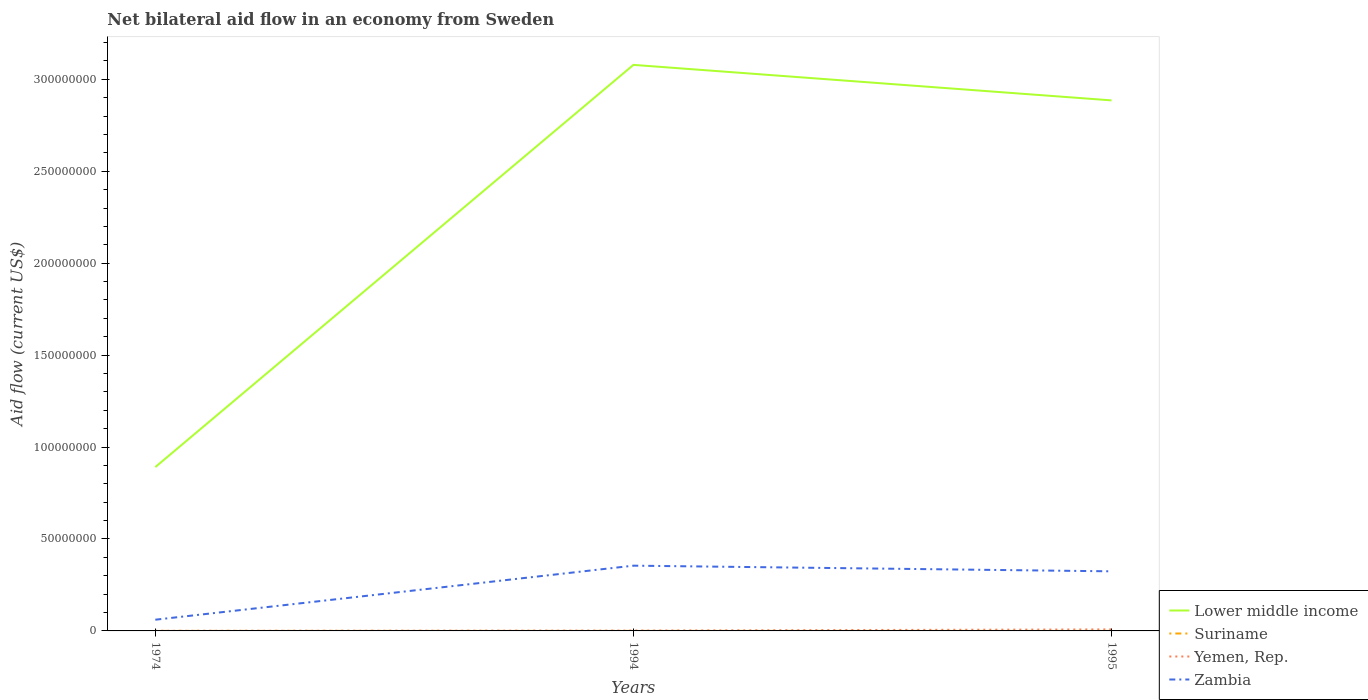Does the line corresponding to Lower middle income intersect with the line corresponding to Zambia?
Ensure brevity in your answer.  No. Is the number of lines equal to the number of legend labels?
Keep it short and to the point. Yes. Across all years, what is the maximum net bilateral aid flow in Yemen, Rep.?
Provide a succinct answer. 7.00e+04. In which year was the net bilateral aid flow in Zambia maximum?
Ensure brevity in your answer.  1974. What is the difference between the highest and the second highest net bilateral aid flow in Zambia?
Your answer should be compact. 2.94e+07. How many lines are there?
Offer a very short reply. 4. How many legend labels are there?
Your answer should be compact. 4. What is the title of the graph?
Keep it short and to the point. Net bilateral aid flow in an economy from Sweden. Does "Guinea" appear as one of the legend labels in the graph?
Give a very brief answer. No. What is the label or title of the X-axis?
Ensure brevity in your answer.  Years. What is the Aid flow (current US$) of Lower middle income in 1974?
Your answer should be compact. 8.91e+07. What is the Aid flow (current US$) in Zambia in 1974?
Provide a succinct answer. 6.10e+06. What is the Aid flow (current US$) in Lower middle income in 1994?
Your answer should be very brief. 3.08e+08. What is the Aid flow (current US$) in Suriname in 1994?
Your response must be concise. 2.00e+04. What is the Aid flow (current US$) of Zambia in 1994?
Provide a short and direct response. 3.55e+07. What is the Aid flow (current US$) in Lower middle income in 1995?
Provide a short and direct response. 2.89e+08. What is the Aid flow (current US$) in Suriname in 1995?
Your answer should be very brief. 10000. What is the Aid flow (current US$) of Yemen, Rep. in 1995?
Your answer should be compact. 8.30e+05. What is the Aid flow (current US$) of Zambia in 1995?
Make the answer very short. 3.24e+07. Across all years, what is the maximum Aid flow (current US$) of Lower middle income?
Your answer should be very brief. 3.08e+08. Across all years, what is the maximum Aid flow (current US$) of Suriname?
Provide a short and direct response. 2.00e+04. Across all years, what is the maximum Aid flow (current US$) of Yemen, Rep.?
Offer a very short reply. 8.30e+05. Across all years, what is the maximum Aid flow (current US$) in Zambia?
Offer a terse response. 3.55e+07. Across all years, what is the minimum Aid flow (current US$) of Lower middle income?
Provide a short and direct response. 8.91e+07. Across all years, what is the minimum Aid flow (current US$) of Zambia?
Your answer should be compact. 6.10e+06. What is the total Aid flow (current US$) of Lower middle income in the graph?
Your answer should be very brief. 6.86e+08. What is the total Aid flow (current US$) in Yemen, Rep. in the graph?
Provide a short and direct response. 1.09e+06. What is the total Aid flow (current US$) in Zambia in the graph?
Offer a very short reply. 7.40e+07. What is the difference between the Aid flow (current US$) of Lower middle income in 1974 and that in 1994?
Make the answer very short. -2.19e+08. What is the difference between the Aid flow (current US$) of Suriname in 1974 and that in 1994?
Provide a short and direct response. 0. What is the difference between the Aid flow (current US$) of Zambia in 1974 and that in 1994?
Provide a short and direct response. -2.94e+07. What is the difference between the Aid flow (current US$) in Lower middle income in 1974 and that in 1995?
Provide a succinct answer. -1.99e+08. What is the difference between the Aid flow (current US$) in Suriname in 1974 and that in 1995?
Offer a very short reply. 10000. What is the difference between the Aid flow (current US$) in Yemen, Rep. in 1974 and that in 1995?
Offer a terse response. -7.60e+05. What is the difference between the Aid flow (current US$) in Zambia in 1974 and that in 1995?
Provide a short and direct response. -2.63e+07. What is the difference between the Aid flow (current US$) in Lower middle income in 1994 and that in 1995?
Provide a succinct answer. 1.93e+07. What is the difference between the Aid flow (current US$) of Yemen, Rep. in 1994 and that in 1995?
Provide a short and direct response. -6.40e+05. What is the difference between the Aid flow (current US$) in Zambia in 1994 and that in 1995?
Your answer should be compact. 3.08e+06. What is the difference between the Aid flow (current US$) in Lower middle income in 1974 and the Aid flow (current US$) in Suriname in 1994?
Your answer should be compact. 8.91e+07. What is the difference between the Aid flow (current US$) of Lower middle income in 1974 and the Aid flow (current US$) of Yemen, Rep. in 1994?
Provide a succinct answer. 8.89e+07. What is the difference between the Aid flow (current US$) in Lower middle income in 1974 and the Aid flow (current US$) in Zambia in 1994?
Make the answer very short. 5.36e+07. What is the difference between the Aid flow (current US$) in Suriname in 1974 and the Aid flow (current US$) in Zambia in 1994?
Ensure brevity in your answer.  -3.55e+07. What is the difference between the Aid flow (current US$) in Yemen, Rep. in 1974 and the Aid flow (current US$) in Zambia in 1994?
Your answer should be compact. -3.54e+07. What is the difference between the Aid flow (current US$) of Lower middle income in 1974 and the Aid flow (current US$) of Suriname in 1995?
Provide a succinct answer. 8.91e+07. What is the difference between the Aid flow (current US$) of Lower middle income in 1974 and the Aid flow (current US$) of Yemen, Rep. in 1995?
Your response must be concise. 8.83e+07. What is the difference between the Aid flow (current US$) of Lower middle income in 1974 and the Aid flow (current US$) of Zambia in 1995?
Keep it short and to the point. 5.67e+07. What is the difference between the Aid flow (current US$) in Suriname in 1974 and the Aid flow (current US$) in Yemen, Rep. in 1995?
Ensure brevity in your answer.  -8.10e+05. What is the difference between the Aid flow (current US$) in Suriname in 1974 and the Aid flow (current US$) in Zambia in 1995?
Offer a terse response. -3.24e+07. What is the difference between the Aid flow (current US$) of Yemen, Rep. in 1974 and the Aid flow (current US$) of Zambia in 1995?
Offer a very short reply. -3.23e+07. What is the difference between the Aid flow (current US$) of Lower middle income in 1994 and the Aid flow (current US$) of Suriname in 1995?
Offer a very short reply. 3.08e+08. What is the difference between the Aid flow (current US$) in Lower middle income in 1994 and the Aid flow (current US$) in Yemen, Rep. in 1995?
Give a very brief answer. 3.07e+08. What is the difference between the Aid flow (current US$) in Lower middle income in 1994 and the Aid flow (current US$) in Zambia in 1995?
Make the answer very short. 2.75e+08. What is the difference between the Aid flow (current US$) of Suriname in 1994 and the Aid flow (current US$) of Yemen, Rep. in 1995?
Offer a terse response. -8.10e+05. What is the difference between the Aid flow (current US$) in Suriname in 1994 and the Aid flow (current US$) in Zambia in 1995?
Offer a very short reply. -3.24e+07. What is the difference between the Aid flow (current US$) in Yemen, Rep. in 1994 and the Aid flow (current US$) in Zambia in 1995?
Keep it short and to the point. -3.22e+07. What is the average Aid flow (current US$) in Lower middle income per year?
Offer a terse response. 2.28e+08. What is the average Aid flow (current US$) in Suriname per year?
Keep it short and to the point. 1.67e+04. What is the average Aid flow (current US$) in Yemen, Rep. per year?
Ensure brevity in your answer.  3.63e+05. What is the average Aid flow (current US$) of Zambia per year?
Ensure brevity in your answer.  2.47e+07. In the year 1974, what is the difference between the Aid flow (current US$) in Lower middle income and Aid flow (current US$) in Suriname?
Your answer should be very brief. 8.91e+07. In the year 1974, what is the difference between the Aid flow (current US$) in Lower middle income and Aid flow (current US$) in Yemen, Rep.?
Make the answer very short. 8.90e+07. In the year 1974, what is the difference between the Aid flow (current US$) of Lower middle income and Aid flow (current US$) of Zambia?
Your answer should be very brief. 8.30e+07. In the year 1974, what is the difference between the Aid flow (current US$) in Suriname and Aid flow (current US$) in Zambia?
Provide a short and direct response. -6.08e+06. In the year 1974, what is the difference between the Aid flow (current US$) of Yemen, Rep. and Aid flow (current US$) of Zambia?
Make the answer very short. -6.03e+06. In the year 1994, what is the difference between the Aid flow (current US$) in Lower middle income and Aid flow (current US$) in Suriname?
Your response must be concise. 3.08e+08. In the year 1994, what is the difference between the Aid flow (current US$) in Lower middle income and Aid flow (current US$) in Yemen, Rep.?
Your response must be concise. 3.08e+08. In the year 1994, what is the difference between the Aid flow (current US$) in Lower middle income and Aid flow (current US$) in Zambia?
Make the answer very short. 2.72e+08. In the year 1994, what is the difference between the Aid flow (current US$) of Suriname and Aid flow (current US$) of Yemen, Rep.?
Provide a short and direct response. -1.70e+05. In the year 1994, what is the difference between the Aid flow (current US$) of Suriname and Aid flow (current US$) of Zambia?
Your response must be concise. -3.55e+07. In the year 1994, what is the difference between the Aid flow (current US$) in Yemen, Rep. and Aid flow (current US$) in Zambia?
Your answer should be compact. -3.53e+07. In the year 1995, what is the difference between the Aid flow (current US$) in Lower middle income and Aid flow (current US$) in Suriname?
Give a very brief answer. 2.89e+08. In the year 1995, what is the difference between the Aid flow (current US$) of Lower middle income and Aid flow (current US$) of Yemen, Rep.?
Offer a very short reply. 2.88e+08. In the year 1995, what is the difference between the Aid flow (current US$) in Lower middle income and Aid flow (current US$) in Zambia?
Provide a short and direct response. 2.56e+08. In the year 1995, what is the difference between the Aid flow (current US$) in Suriname and Aid flow (current US$) in Yemen, Rep.?
Your answer should be very brief. -8.20e+05. In the year 1995, what is the difference between the Aid flow (current US$) of Suriname and Aid flow (current US$) of Zambia?
Provide a short and direct response. -3.24e+07. In the year 1995, what is the difference between the Aid flow (current US$) in Yemen, Rep. and Aid flow (current US$) in Zambia?
Make the answer very short. -3.16e+07. What is the ratio of the Aid flow (current US$) in Lower middle income in 1974 to that in 1994?
Make the answer very short. 0.29. What is the ratio of the Aid flow (current US$) in Yemen, Rep. in 1974 to that in 1994?
Provide a succinct answer. 0.37. What is the ratio of the Aid flow (current US$) in Zambia in 1974 to that in 1994?
Keep it short and to the point. 0.17. What is the ratio of the Aid flow (current US$) in Lower middle income in 1974 to that in 1995?
Make the answer very short. 0.31. What is the ratio of the Aid flow (current US$) in Suriname in 1974 to that in 1995?
Your answer should be very brief. 2. What is the ratio of the Aid flow (current US$) of Yemen, Rep. in 1974 to that in 1995?
Keep it short and to the point. 0.08. What is the ratio of the Aid flow (current US$) of Zambia in 1974 to that in 1995?
Ensure brevity in your answer.  0.19. What is the ratio of the Aid flow (current US$) of Lower middle income in 1994 to that in 1995?
Your answer should be compact. 1.07. What is the ratio of the Aid flow (current US$) in Yemen, Rep. in 1994 to that in 1995?
Give a very brief answer. 0.23. What is the ratio of the Aid flow (current US$) of Zambia in 1994 to that in 1995?
Give a very brief answer. 1.09. What is the difference between the highest and the second highest Aid flow (current US$) of Lower middle income?
Give a very brief answer. 1.93e+07. What is the difference between the highest and the second highest Aid flow (current US$) of Suriname?
Give a very brief answer. 0. What is the difference between the highest and the second highest Aid flow (current US$) in Yemen, Rep.?
Your response must be concise. 6.40e+05. What is the difference between the highest and the second highest Aid flow (current US$) in Zambia?
Offer a very short reply. 3.08e+06. What is the difference between the highest and the lowest Aid flow (current US$) of Lower middle income?
Keep it short and to the point. 2.19e+08. What is the difference between the highest and the lowest Aid flow (current US$) of Suriname?
Give a very brief answer. 10000. What is the difference between the highest and the lowest Aid flow (current US$) in Yemen, Rep.?
Make the answer very short. 7.60e+05. What is the difference between the highest and the lowest Aid flow (current US$) of Zambia?
Provide a short and direct response. 2.94e+07. 